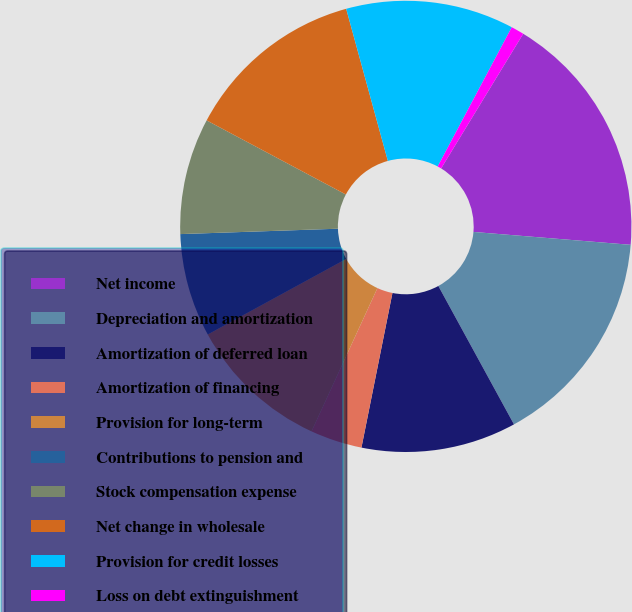<chart> <loc_0><loc_0><loc_500><loc_500><pie_chart><fcel>Net income<fcel>Depreciation and amortization<fcel>Amortization of deferred loan<fcel>Amortization of financing<fcel>Provision for long-term<fcel>Contributions to pension and<fcel>Stock compensation expense<fcel>Net change in wholesale<fcel>Provision for credit losses<fcel>Loss on debt extinguishment<nl><fcel>17.59%<fcel>15.74%<fcel>11.11%<fcel>3.71%<fcel>10.19%<fcel>7.41%<fcel>8.33%<fcel>12.96%<fcel>12.04%<fcel>0.93%<nl></chart> 